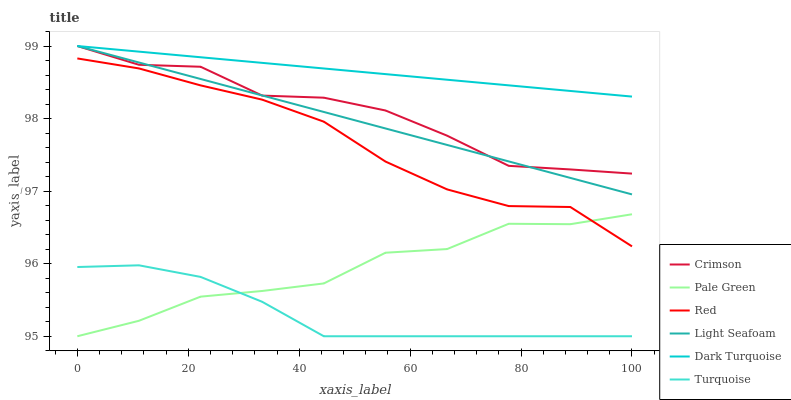Does Pale Green have the minimum area under the curve?
Answer yes or no. No. Does Pale Green have the maximum area under the curve?
Answer yes or no. No. Is Dark Turquoise the smoothest?
Answer yes or no. No. Is Dark Turquoise the roughest?
Answer yes or no. No. Does Dark Turquoise have the lowest value?
Answer yes or no. No. Does Pale Green have the highest value?
Answer yes or no. No. Is Turquoise less than Light Seafoam?
Answer yes or no. Yes. Is Dark Turquoise greater than Pale Green?
Answer yes or no. Yes. Does Turquoise intersect Light Seafoam?
Answer yes or no. No. 